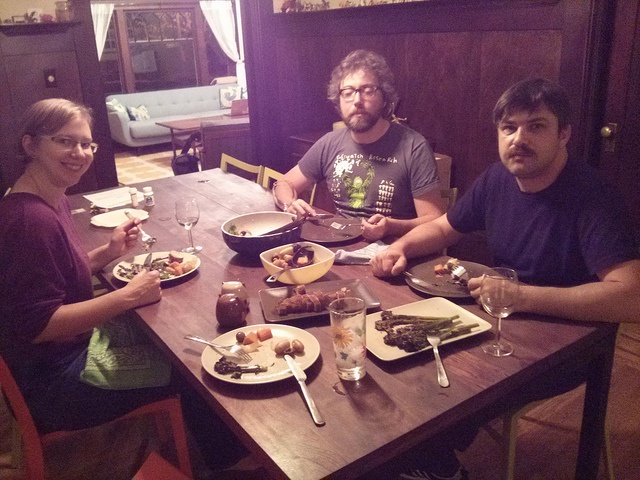Describe the objects in this image and their specific colors. I can see dining table in tan, brown, black, lightpink, and lightgray tones, people in tan, black, brown, and purple tones, people in tan, navy, purple, and maroon tones, people in tan, brown, purple, and lightpink tones, and chair in tan, black, maroon, and brown tones in this image. 